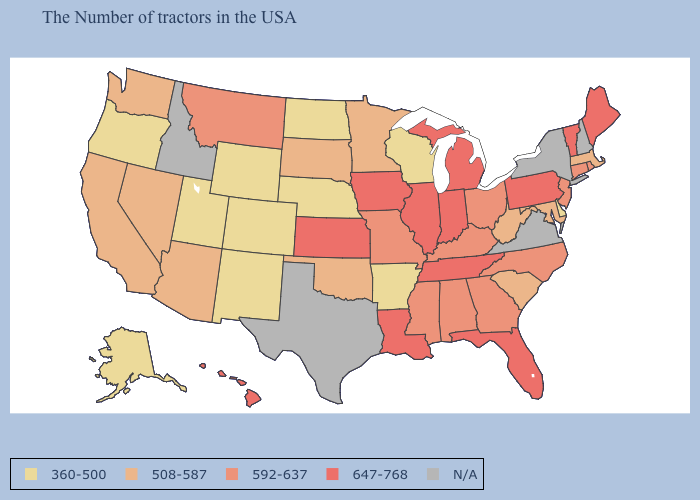What is the highest value in states that border Utah?
Write a very short answer. 508-587. Does Mississippi have the lowest value in the USA?
Short answer required. No. Which states have the lowest value in the South?
Answer briefly. Delaware, Arkansas. What is the value of Washington?
Short answer required. 508-587. Does the first symbol in the legend represent the smallest category?
Short answer required. Yes. Among the states that border Connecticut , does Massachusetts have the lowest value?
Short answer required. Yes. Which states have the lowest value in the USA?
Write a very short answer. Delaware, Wisconsin, Arkansas, Nebraska, North Dakota, Wyoming, Colorado, New Mexico, Utah, Oregon, Alaska. Does Oregon have the lowest value in the West?
Keep it brief. Yes. What is the value of Alaska?
Concise answer only. 360-500. What is the value of Maryland?
Be succinct. 508-587. Does Maryland have the highest value in the USA?
Keep it brief. No. What is the value of Massachusetts?
Short answer required. 508-587. Name the states that have a value in the range 360-500?
Quick response, please. Delaware, Wisconsin, Arkansas, Nebraska, North Dakota, Wyoming, Colorado, New Mexico, Utah, Oregon, Alaska. 